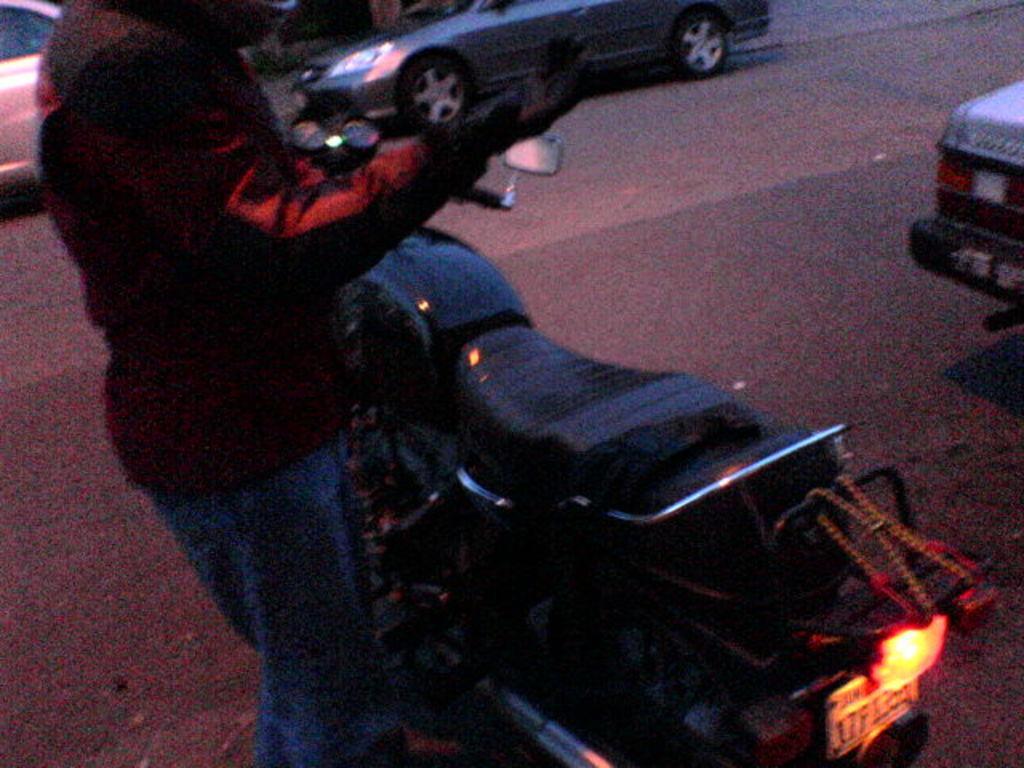In one or two sentences, can you explain what this image depicts? In this image there are cars, a bike and the person on the road. 